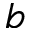Convert formula to latex. <formula><loc_0><loc_0><loc_500><loc_500>b</formula> 